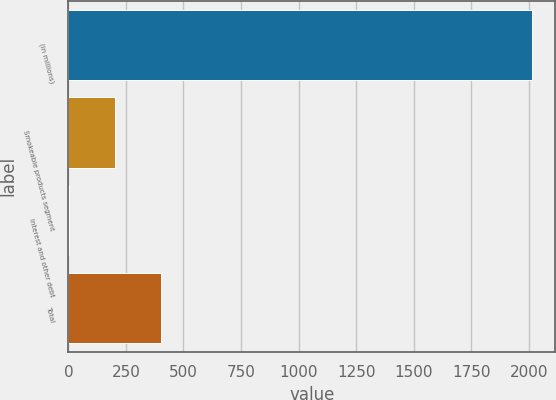Convert chart. <chart><loc_0><loc_0><loc_500><loc_500><bar_chart><fcel>(in millions)<fcel>Smokeable products segment<fcel>Interest and other debt<fcel>Total<nl><fcel>2014<fcel>203.2<fcel>2<fcel>404.4<nl></chart> 